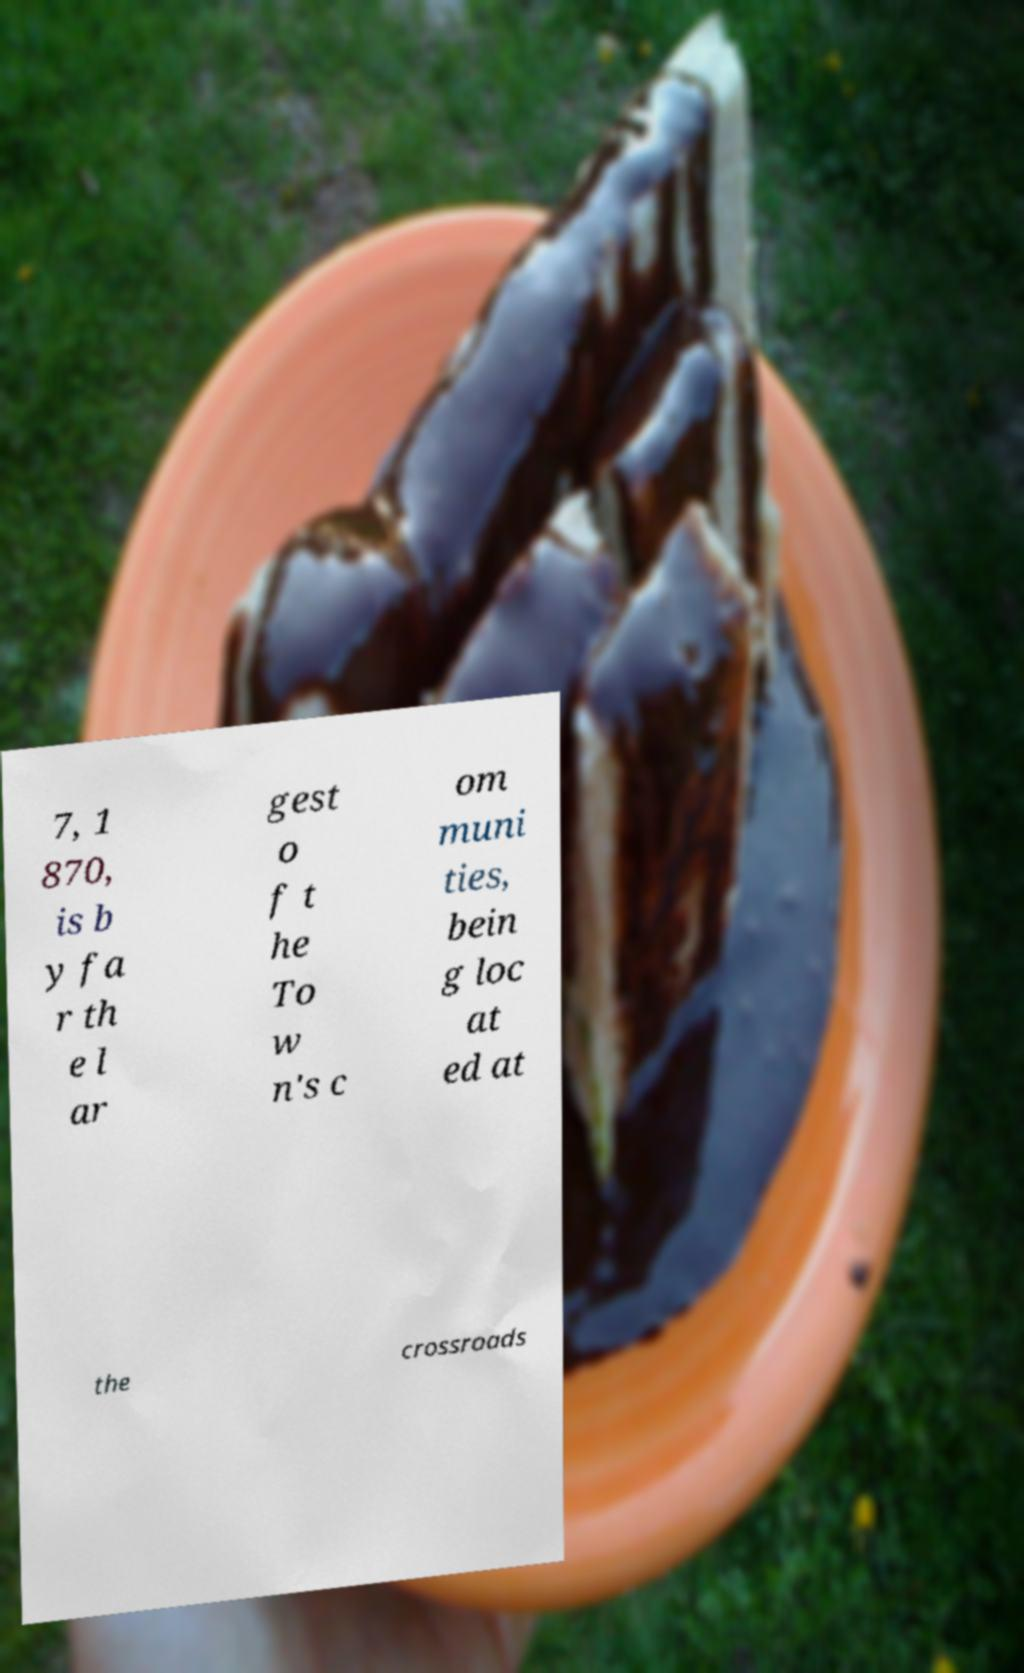Can you accurately transcribe the text from the provided image for me? 7, 1 870, is b y fa r th e l ar gest o f t he To w n's c om muni ties, bein g loc at ed at the crossroads 